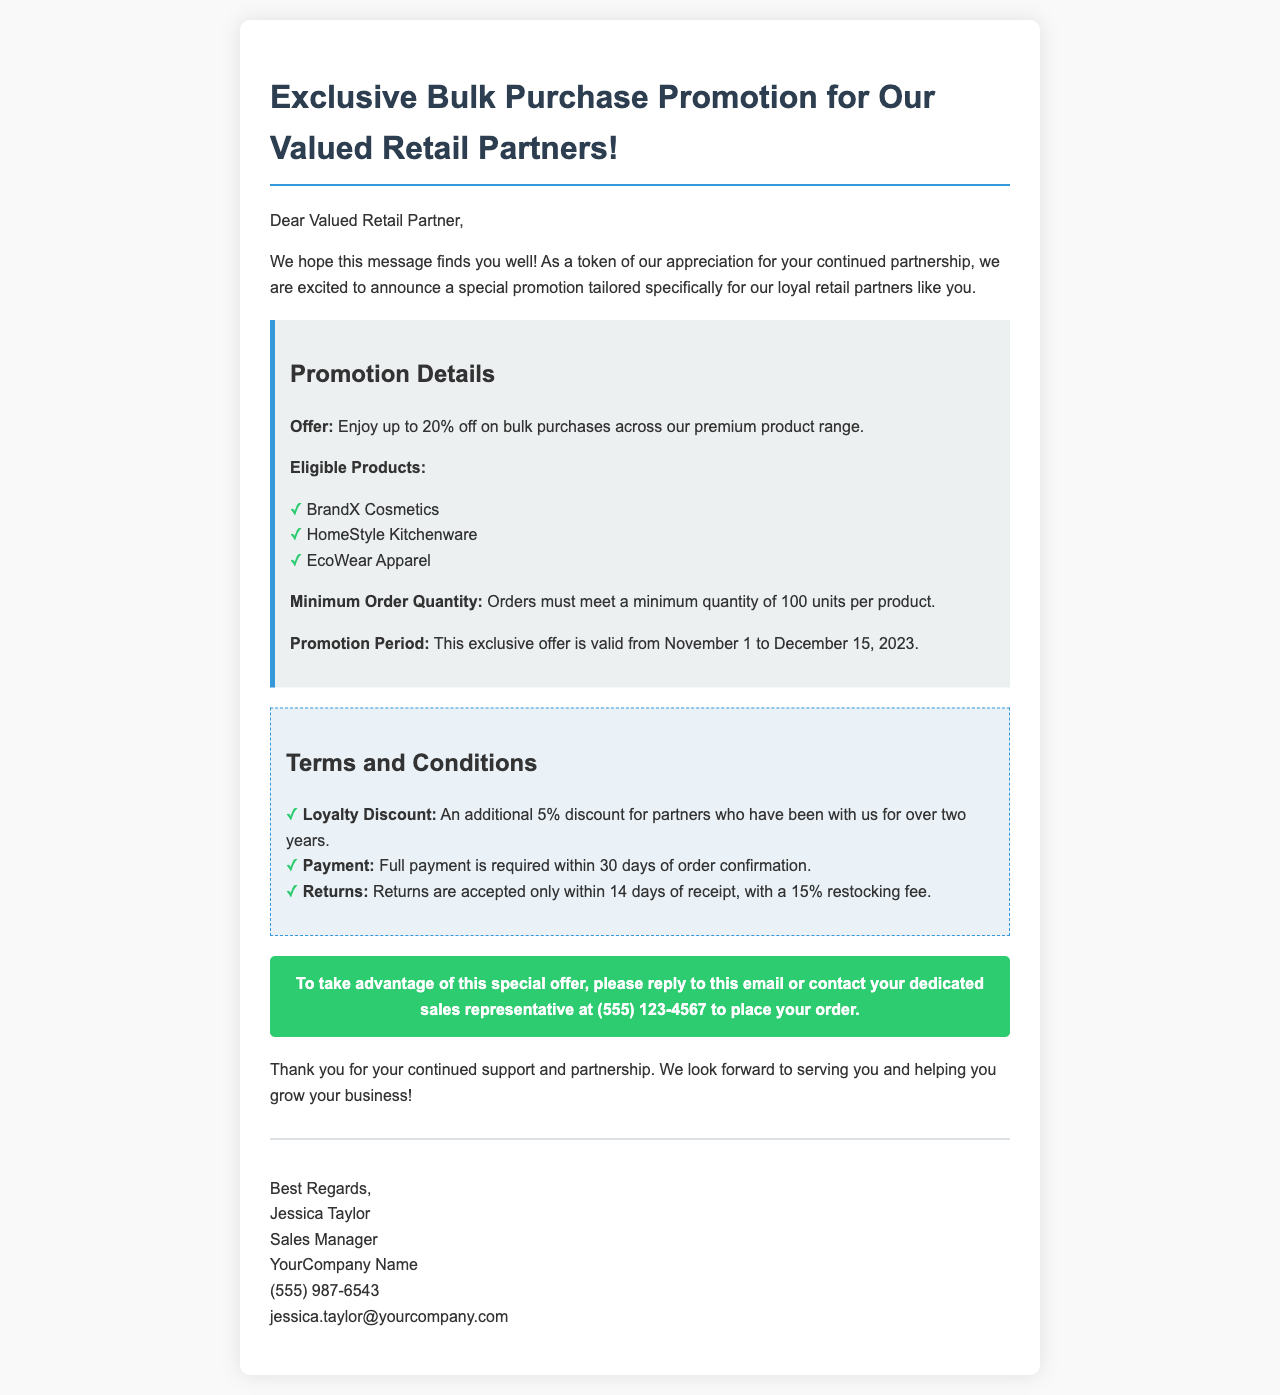What is the maximum discount for bulk purchases? The document states that the offer is up to 20% off on bulk purchases.
Answer: 20% What is the minimum order quantity required for the promotion? The document mentions that orders must meet a minimum quantity of 100 units per product.
Answer: 100 units What is the promotion period? The promotion is valid from November 1 to December 15, 2023.
Answer: November 1 to December 15, 2023 Who is the Sales Manager? The document specifies Jessica Taylor as the Sales Manager.
Answer: Jessica Taylor Is there an additional discount for long-term partners? The document indicates that there is an additional 5% discount for partners who have been with the company for over two years.
Answer: 5% What is the restocking fee for returns? The document states that there is a 15% restocking fee for returns accepted within 14 days of receipt.
Answer: 15% How can partners take advantage of this special offer? The document suggests replying to the email or contacting the sales representative to place an order.
Answer: Reply to this email or contact your dedicated sales representative What is the payment requirement after order confirmation? The document specifies that full payment is required within 30 days of order confirmation.
Answer: Within 30 days 